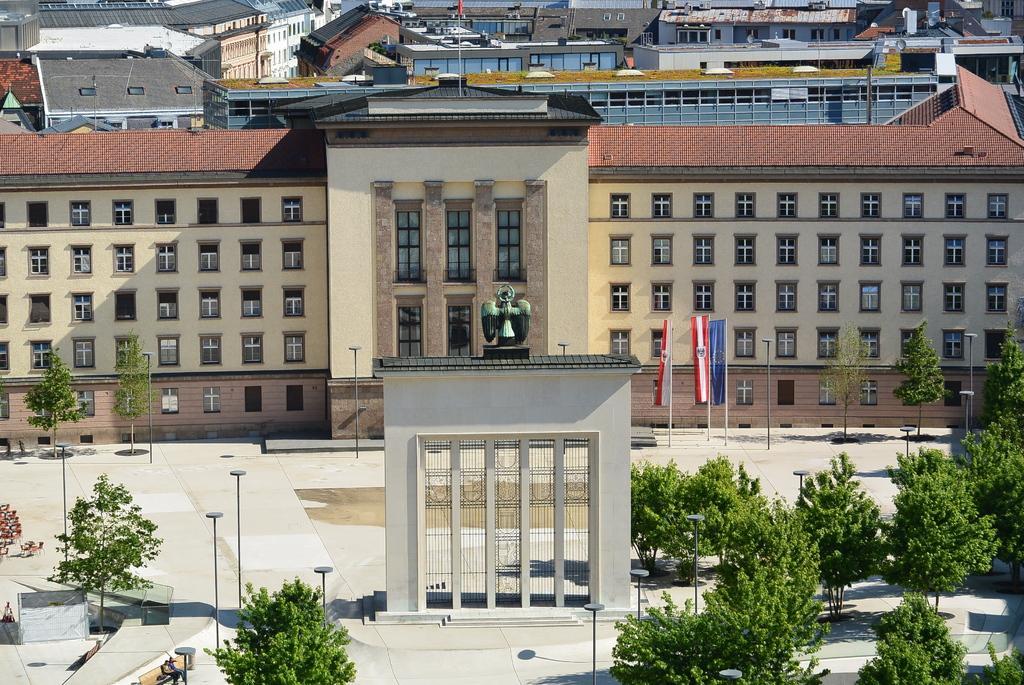Describe this image in one or two sentences. This picture might be taken from outside of the building. In this image, on the right side, we can see some trees and plants. On the left side, we can see some pole, trees, plants. In the middle of the image, we can see an arch. In the background, we can see some flags, trees, statue, building, glass window, houses. 